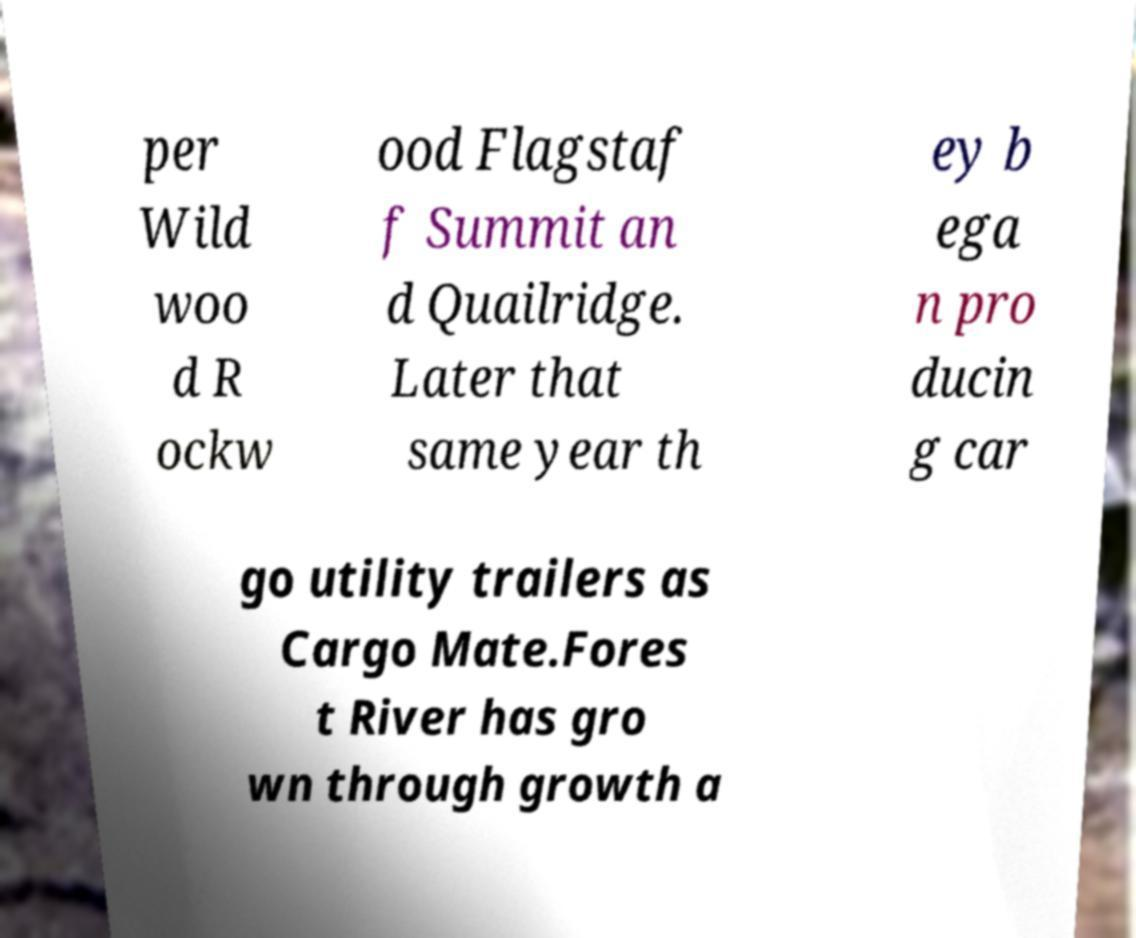Please read and relay the text visible in this image. What does it say? per Wild woo d R ockw ood Flagstaf f Summit an d Quailridge. Later that same year th ey b ega n pro ducin g car go utility trailers as Cargo Mate.Fores t River has gro wn through growth a 